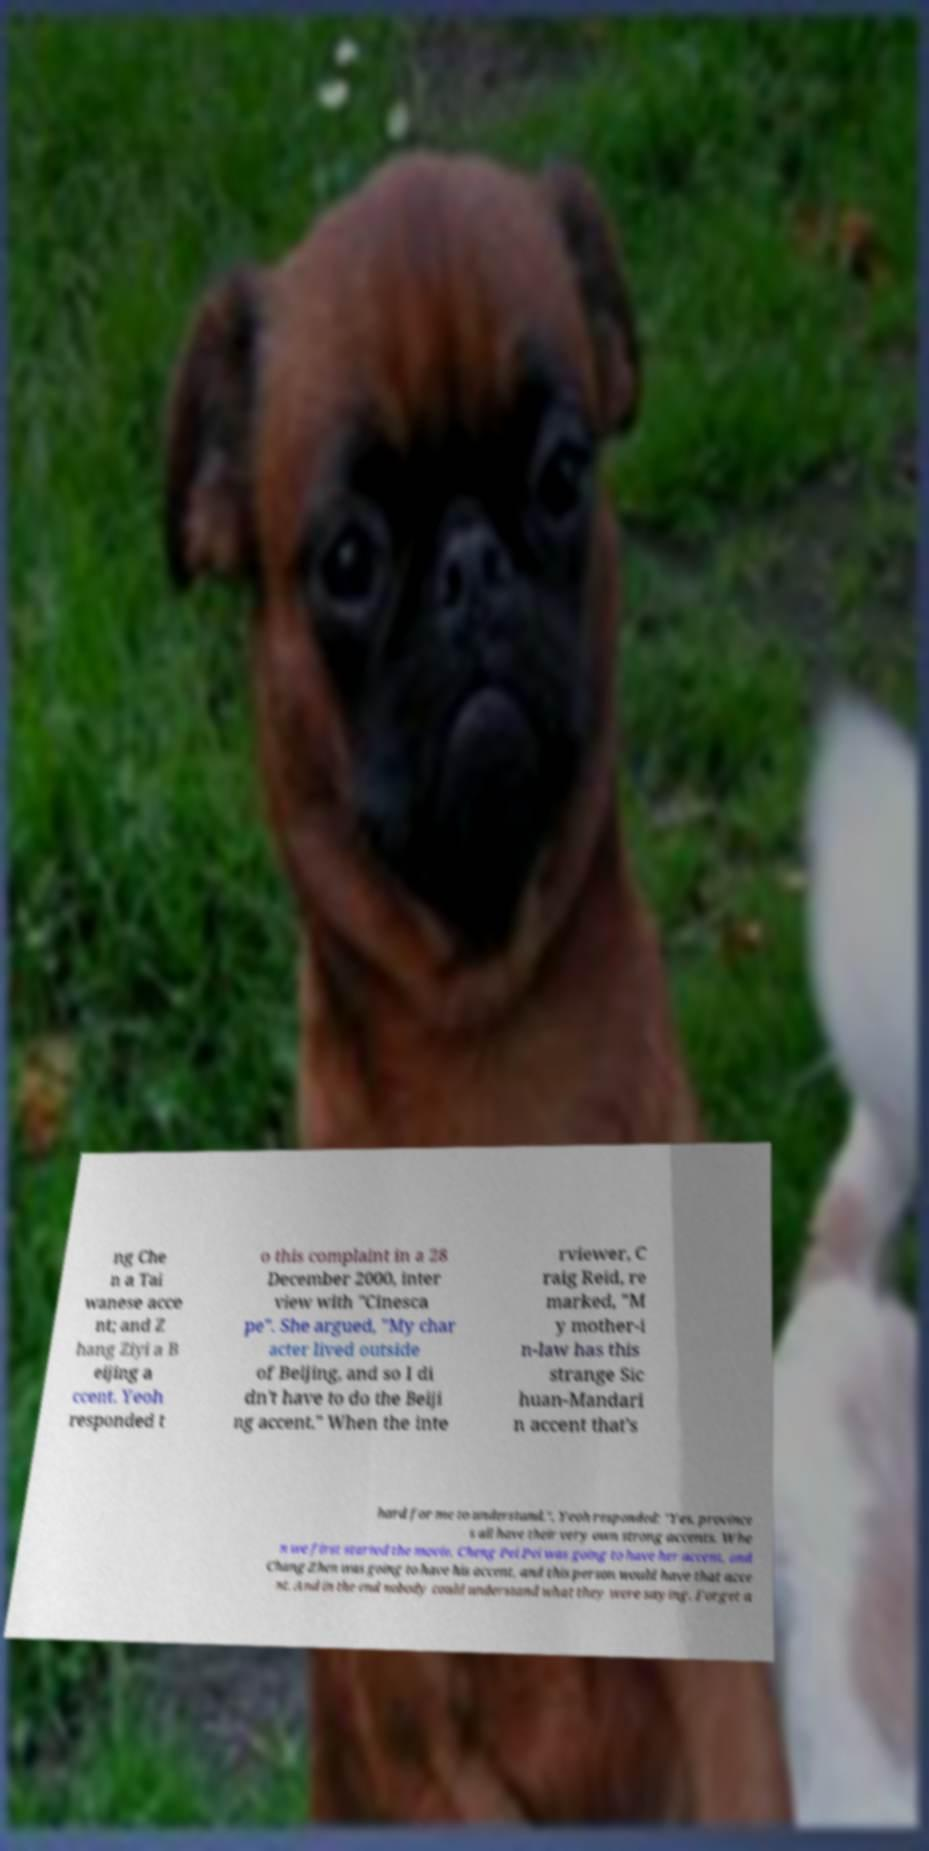Could you assist in decoding the text presented in this image and type it out clearly? ng Che n a Tai wanese acce nt; and Z hang Ziyi a B eijing a ccent. Yeoh responded t o this complaint in a 28 December 2000, inter view with "Cinesca pe". She argued, "My char acter lived outside of Beijing, and so I di dn't have to do the Beiji ng accent." When the inte rviewer, C raig Reid, re marked, "M y mother-i n-law has this strange Sic huan-Mandari n accent that's hard for me to understand.", Yeoh responded: "Yes, province s all have their very own strong accents. Whe n we first started the movie, Cheng Pei Pei was going to have her accent, and Chang Zhen was going to have his accent, and this person would have that acce nt. And in the end nobody could understand what they were saying. Forget a 